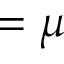<formula> <loc_0><loc_0><loc_500><loc_500>= \mu</formula> 